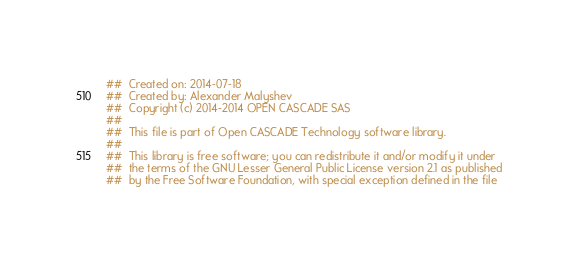Convert code to text. <code><loc_0><loc_0><loc_500><loc_500><_Nim_>##  Created on: 2014-07-18
##  Created by: Alexander Malyshev
##  Copyright (c) 2014-2014 OPEN CASCADE SAS
##
##  This file is part of Open CASCADE Technology software library.
##
##  This library is free software; you can redistribute it and/or modify it under
##  the terms of the GNU Lesser General Public License version 2.1 as published
##  by the Free Software Foundation, with special exception defined in the file</code> 